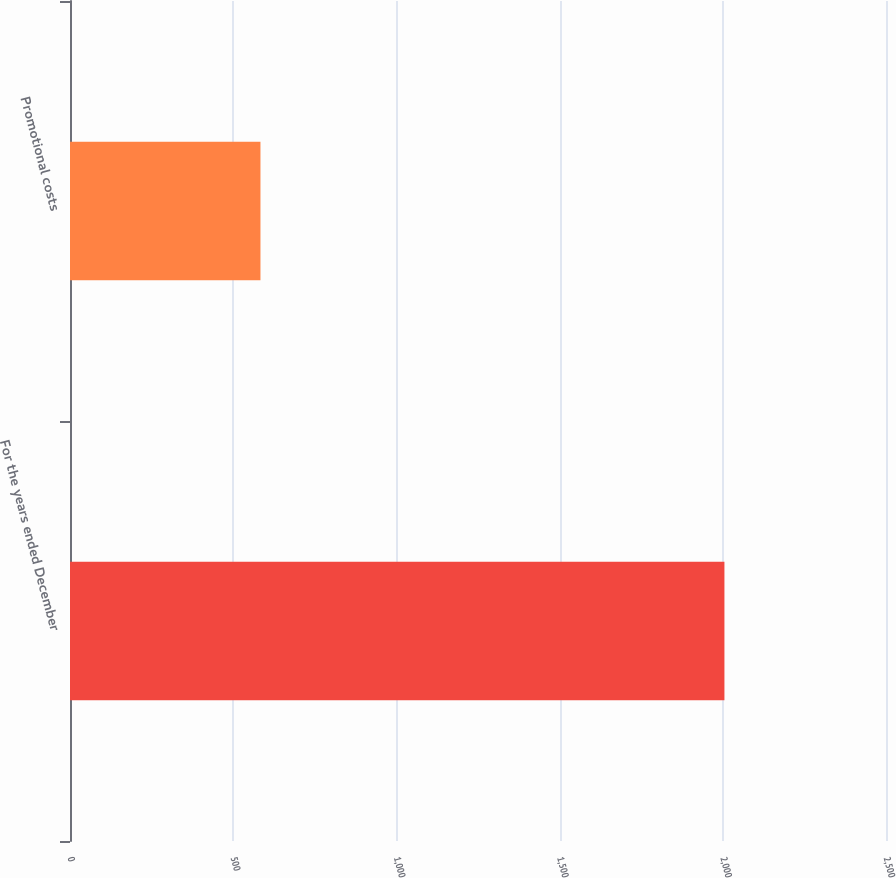<chart> <loc_0><loc_0><loc_500><loc_500><bar_chart><fcel>For the years ended December<fcel>Promotional costs<nl><fcel>2005<fcel>583.5<nl></chart> 